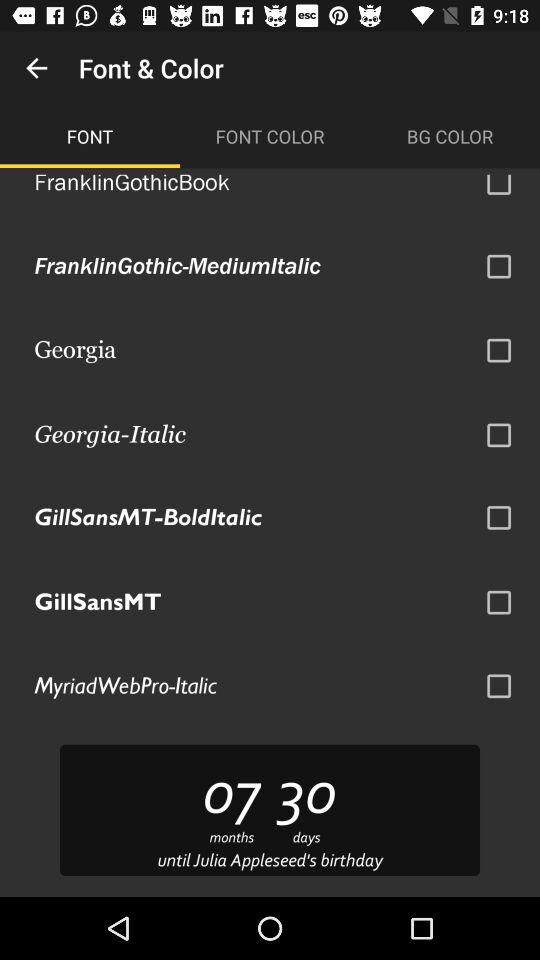How many months and days are left until Julia Appleseed's birthday? There are 7 months and 30 days left until Julia Appleseed's birthday. 